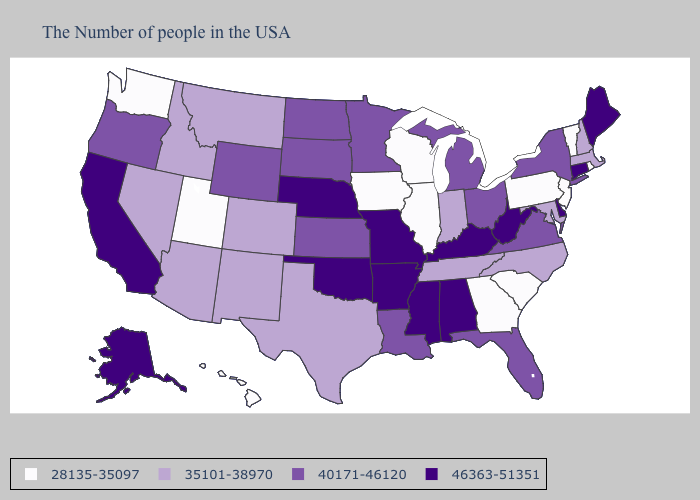How many symbols are there in the legend?
Concise answer only. 4. Does Pennsylvania have the lowest value in the Northeast?
Write a very short answer. Yes. Does Connecticut have the same value as Mississippi?
Concise answer only. Yes. Name the states that have a value in the range 28135-35097?
Answer briefly. Rhode Island, Vermont, New Jersey, Pennsylvania, South Carolina, Georgia, Wisconsin, Illinois, Iowa, Utah, Washington, Hawaii. What is the value of Washington?
Keep it brief. 28135-35097. Among the states that border Montana , which have the highest value?
Give a very brief answer. South Dakota, North Dakota, Wyoming. Among the states that border Minnesota , which have the highest value?
Answer briefly. South Dakota, North Dakota. Among the states that border Montana , does Idaho have the highest value?
Keep it brief. No. Among the states that border Oregon , does Idaho have the lowest value?
Write a very short answer. No. What is the highest value in the USA?
Concise answer only. 46363-51351. Is the legend a continuous bar?
Concise answer only. No. Does Kentucky have the same value as Utah?
Give a very brief answer. No. What is the lowest value in the MidWest?
Concise answer only. 28135-35097. What is the value of New Hampshire?
Give a very brief answer. 35101-38970. 